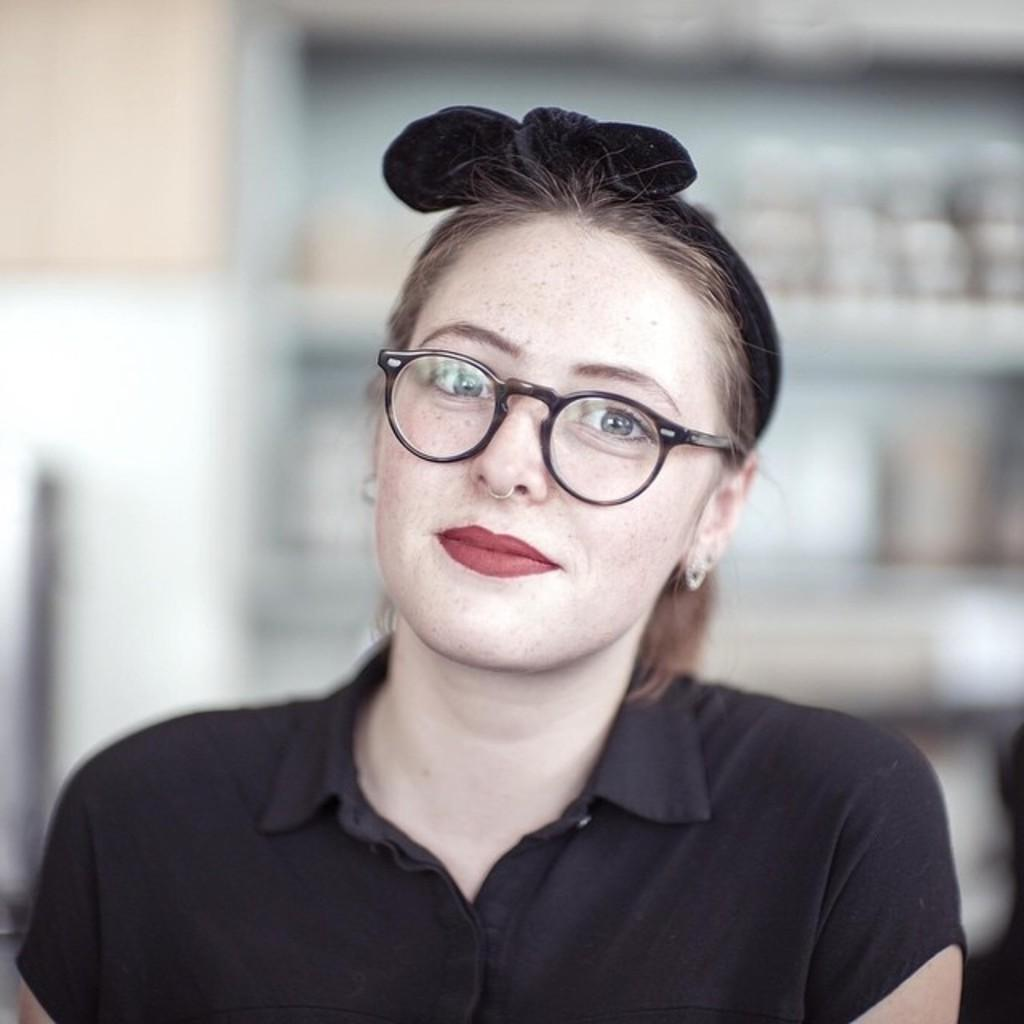Who is the main subject in the image? There is a woman in the image. What is the woman wearing? The woman is wearing a black dress. Are there any accessories visible on the woman? Yes, the woman is wearing spectacles, a nose ring, and earrings. What can be seen in the background of the image? There is a blurred image in the background of the picture, which appears to be shelves. What type of hate is being expressed by the woman in the image? There is no indication of hate or any negative emotion in the image; the woman is simply depicted wearing a black dress and accessories. 